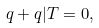Convert formula to latex. <formula><loc_0><loc_0><loc_500><loc_500>q + q | T = 0 ,</formula> 